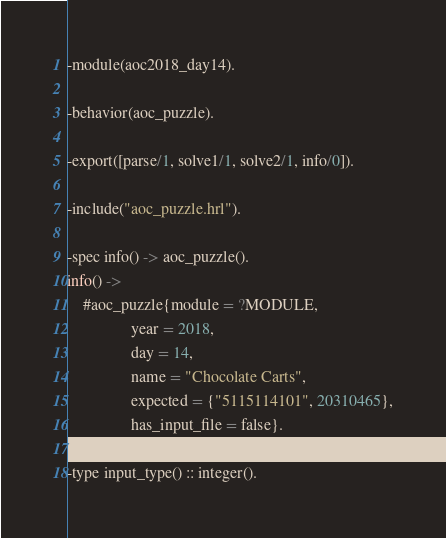Convert code to text. <code><loc_0><loc_0><loc_500><loc_500><_Erlang_>-module(aoc2018_day14).

-behavior(aoc_puzzle).

-export([parse/1, solve1/1, solve2/1, info/0]).

-include("aoc_puzzle.hrl").

-spec info() -> aoc_puzzle().
info() ->
    #aoc_puzzle{module = ?MODULE,
                year = 2018,
                day = 14,
                name = "Chocolate Carts",
                expected = {"5115114101", 20310465},
                has_input_file = false}.

-type input_type() :: integer().</code> 